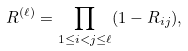Convert formula to latex. <formula><loc_0><loc_0><loc_500><loc_500>R ^ { ( \ell ) } = \prod _ { 1 \leq i < j \leq \ell } ( 1 - R _ { i j } ) ,</formula> 